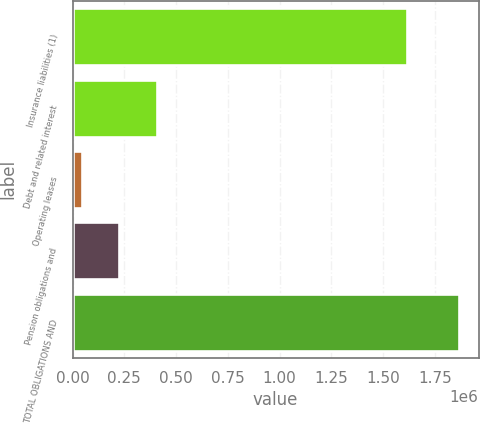Convert chart to OTSL. <chart><loc_0><loc_0><loc_500><loc_500><bar_chart><fcel>Insurance liabilities (1)<fcel>Debt and related interest<fcel>Operating leases<fcel>Pension obligations and<fcel>TOTAL OBLIGATIONS AND<nl><fcel>1.61459e+06<fcel>407819<fcel>43011<fcel>225415<fcel>1.86705e+06<nl></chart> 